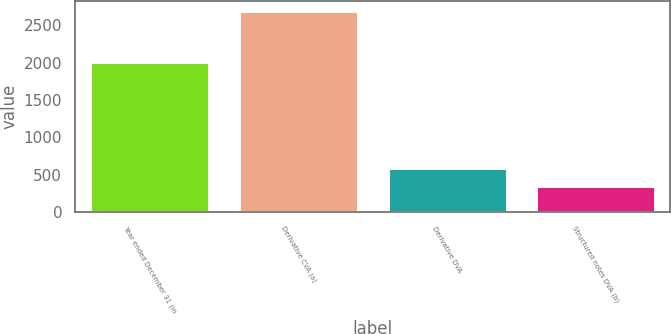<chart> <loc_0><loc_0><loc_500><loc_500><bar_chart><fcel>Year ended December 31 (in<fcel>Derivative CVA (a)<fcel>Derivative DVA<fcel>Structured notes DVA (b)<nl><fcel>2012<fcel>2698<fcel>590<fcel>340<nl></chart> 